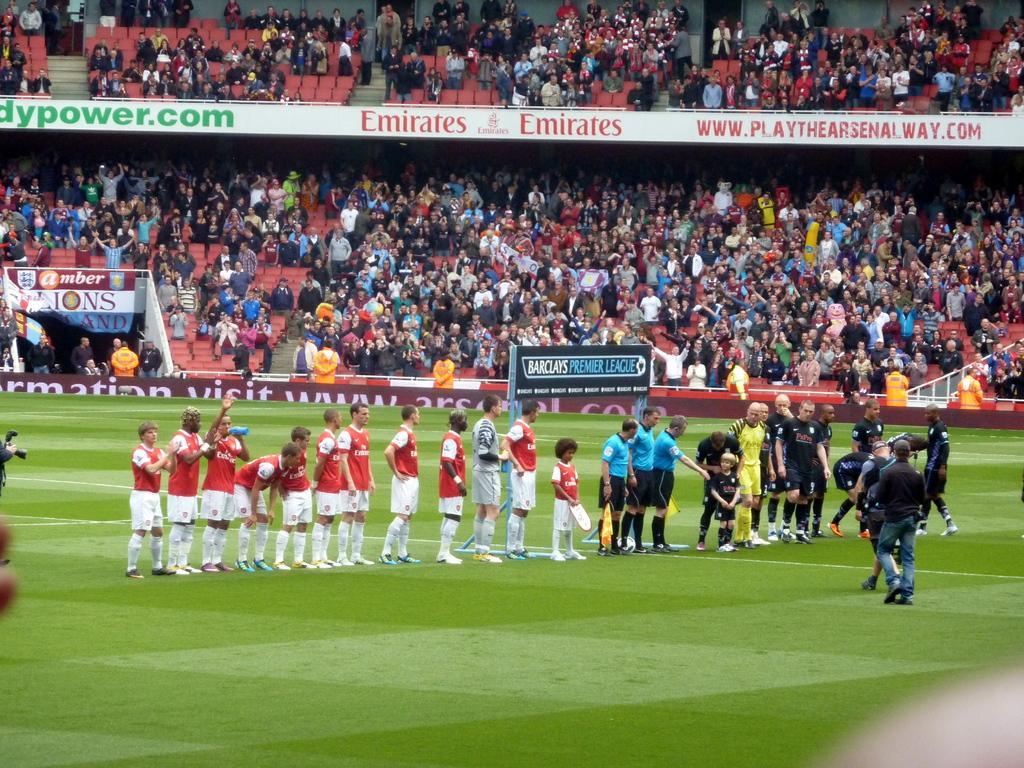<image>
Describe the image concisely. Soccer players take the field at a stadium with an advertisement for Emirates in the stands. 